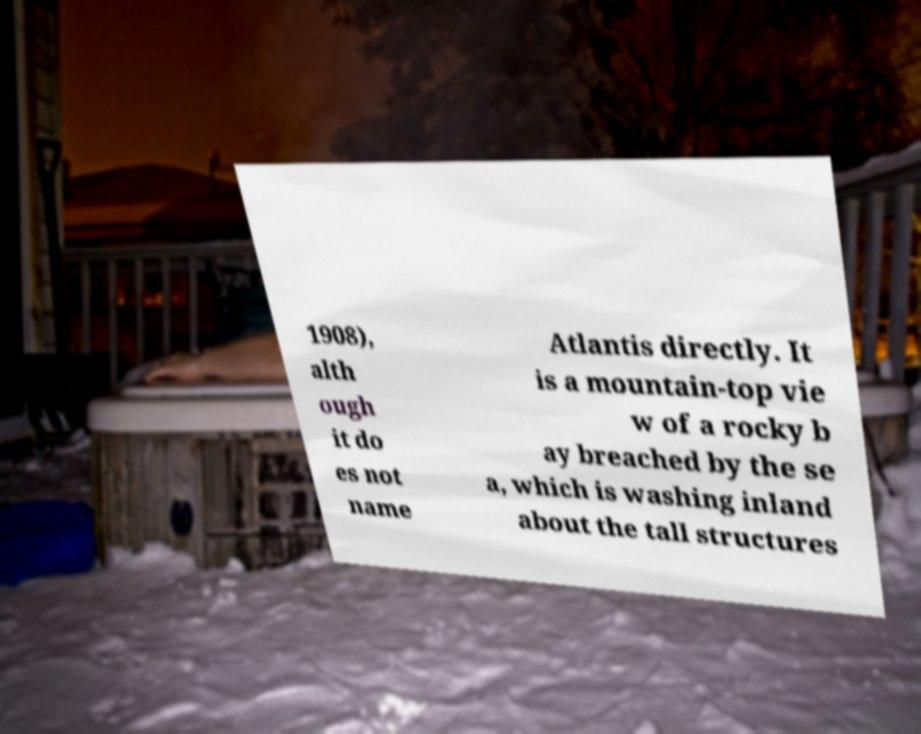There's text embedded in this image that I need extracted. Can you transcribe it verbatim? 1908), alth ough it do es not name Atlantis directly. It is a mountain-top vie w of a rocky b ay breached by the se a, which is washing inland about the tall structures 